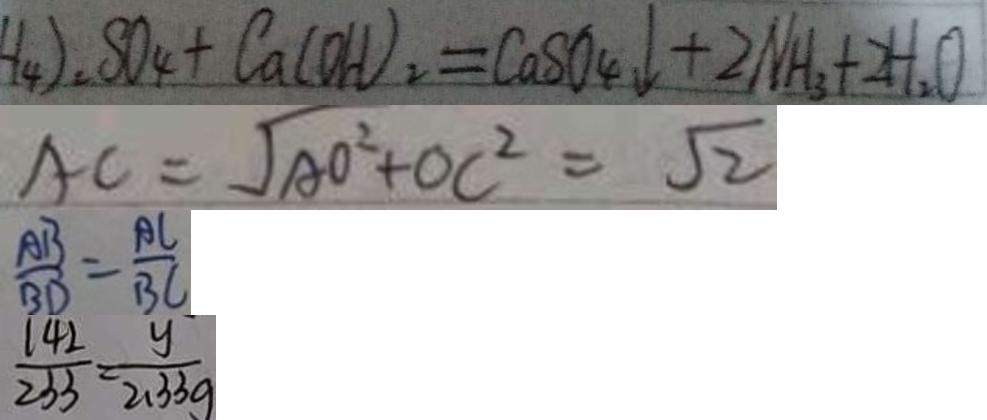Convert formula to latex. <formula><loc_0><loc_0><loc_500><loc_500>H _ { 4 } ) _ { 2 } S O _ { 4 } + C a ( O H ) _ { 2 } = C a S O _ { 4 } \downarrow + 2 N H _ { 3 } + 2 H _ { 2 } O 
 A C = \sqrt { A O ^ { 2 } + O C ^ { 2 } } = \sqrt { 2 } 
 \frac { A B } { B D } = \frac { A C } { B C } 
 \frac { 1 4 2 } { 2 3 3 } = \frac { y } { 2 . 3 3 g }</formula> 